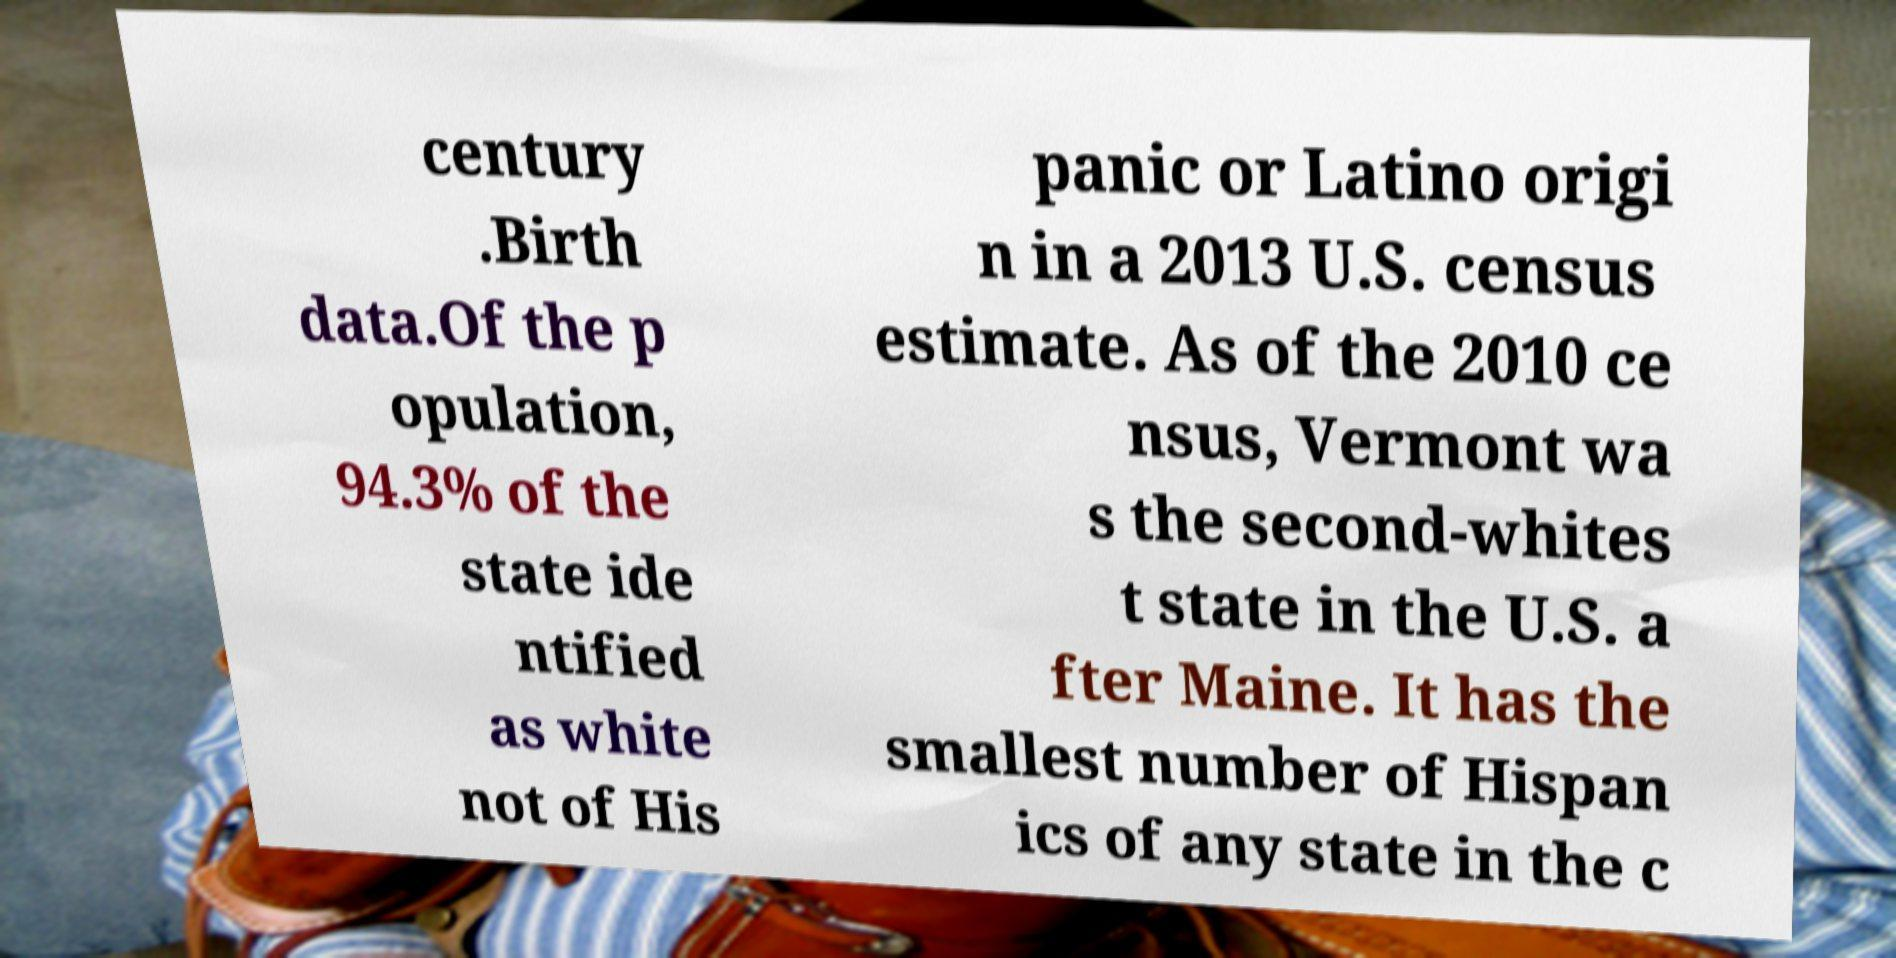What messages or text are displayed in this image? I need them in a readable, typed format. century .Birth data.Of the p opulation, 94.3% of the state ide ntified as white not of His panic or Latino origi n in a 2013 U.S. census estimate. As of the 2010 ce nsus, Vermont wa s the second-whites t state in the U.S. a fter Maine. It has the smallest number of Hispan ics of any state in the c 